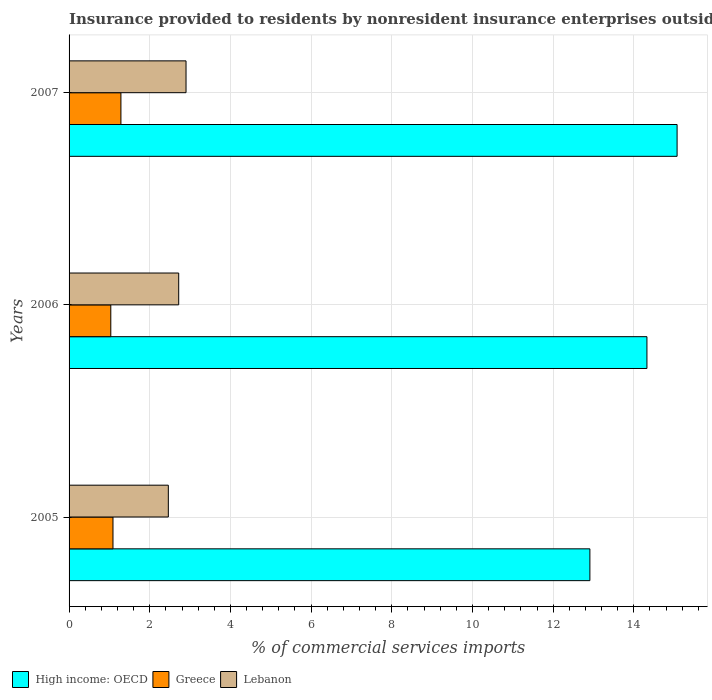How many bars are there on the 3rd tick from the top?
Give a very brief answer. 3. What is the label of the 2nd group of bars from the top?
Give a very brief answer. 2006. In how many cases, is the number of bars for a given year not equal to the number of legend labels?
Give a very brief answer. 0. What is the Insurance provided to residents in High income: OECD in 2006?
Offer a very short reply. 14.33. Across all years, what is the maximum Insurance provided to residents in Lebanon?
Keep it short and to the point. 2.9. Across all years, what is the minimum Insurance provided to residents in Greece?
Keep it short and to the point. 1.03. What is the total Insurance provided to residents in Greece in the graph?
Provide a short and direct response. 3.41. What is the difference between the Insurance provided to residents in Lebanon in 2005 and that in 2006?
Give a very brief answer. -0.26. What is the difference between the Insurance provided to residents in High income: OECD in 2005 and the Insurance provided to residents in Lebanon in 2007?
Offer a terse response. 10.01. What is the average Insurance provided to residents in Lebanon per year?
Keep it short and to the point. 2.69. In the year 2005, what is the difference between the Insurance provided to residents in Greece and Insurance provided to residents in Lebanon?
Give a very brief answer. -1.37. In how many years, is the Insurance provided to residents in High income: OECD greater than 9.2 %?
Offer a terse response. 3. What is the ratio of the Insurance provided to residents in High income: OECD in 2006 to that in 2007?
Provide a succinct answer. 0.95. Is the difference between the Insurance provided to residents in Greece in 2005 and 2007 greater than the difference between the Insurance provided to residents in Lebanon in 2005 and 2007?
Make the answer very short. Yes. What is the difference between the highest and the second highest Insurance provided to residents in Greece?
Provide a short and direct response. 0.2. What is the difference between the highest and the lowest Insurance provided to residents in Greece?
Offer a terse response. 0.25. What does the 1st bar from the bottom in 2006 represents?
Provide a succinct answer. High income: OECD. Are all the bars in the graph horizontal?
Make the answer very short. Yes. What is the difference between two consecutive major ticks on the X-axis?
Provide a short and direct response. 2. How many legend labels are there?
Ensure brevity in your answer.  3. How are the legend labels stacked?
Offer a very short reply. Horizontal. What is the title of the graph?
Offer a very short reply. Insurance provided to residents by nonresident insurance enterprises outside a country. What is the label or title of the X-axis?
Keep it short and to the point. % of commercial services imports. What is the label or title of the Y-axis?
Make the answer very short. Years. What is the % of commercial services imports in High income: OECD in 2005?
Make the answer very short. 12.91. What is the % of commercial services imports in Greece in 2005?
Provide a succinct answer. 1.09. What is the % of commercial services imports in Lebanon in 2005?
Your answer should be compact. 2.46. What is the % of commercial services imports in High income: OECD in 2006?
Provide a short and direct response. 14.33. What is the % of commercial services imports in Greece in 2006?
Keep it short and to the point. 1.03. What is the % of commercial services imports of Lebanon in 2006?
Your response must be concise. 2.72. What is the % of commercial services imports in High income: OECD in 2007?
Ensure brevity in your answer.  15.07. What is the % of commercial services imports in Greece in 2007?
Provide a succinct answer. 1.29. What is the % of commercial services imports in Lebanon in 2007?
Your response must be concise. 2.9. Across all years, what is the maximum % of commercial services imports in High income: OECD?
Provide a succinct answer. 15.07. Across all years, what is the maximum % of commercial services imports of Greece?
Make the answer very short. 1.29. Across all years, what is the maximum % of commercial services imports in Lebanon?
Your answer should be compact. 2.9. Across all years, what is the minimum % of commercial services imports in High income: OECD?
Offer a very short reply. 12.91. Across all years, what is the minimum % of commercial services imports of Greece?
Provide a succinct answer. 1.03. Across all years, what is the minimum % of commercial services imports in Lebanon?
Provide a short and direct response. 2.46. What is the total % of commercial services imports of High income: OECD in the graph?
Ensure brevity in your answer.  42.31. What is the total % of commercial services imports in Greece in the graph?
Provide a succinct answer. 3.41. What is the total % of commercial services imports in Lebanon in the graph?
Your answer should be very brief. 8.08. What is the difference between the % of commercial services imports of High income: OECD in 2005 and that in 2006?
Provide a succinct answer. -1.41. What is the difference between the % of commercial services imports in Greece in 2005 and that in 2006?
Provide a short and direct response. 0.05. What is the difference between the % of commercial services imports in Lebanon in 2005 and that in 2006?
Offer a terse response. -0.26. What is the difference between the % of commercial services imports in High income: OECD in 2005 and that in 2007?
Make the answer very short. -2.16. What is the difference between the % of commercial services imports in Greece in 2005 and that in 2007?
Your response must be concise. -0.2. What is the difference between the % of commercial services imports in Lebanon in 2005 and that in 2007?
Provide a succinct answer. -0.44. What is the difference between the % of commercial services imports in High income: OECD in 2006 and that in 2007?
Keep it short and to the point. -0.75. What is the difference between the % of commercial services imports in Greece in 2006 and that in 2007?
Your answer should be compact. -0.25. What is the difference between the % of commercial services imports in Lebanon in 2006 and that in 2007?
Offer a very short reply. -0.18. What is the difference between the % of commercial services imports of High income: OECD in 2005 and the % of commercial services imports of Greece in 2006?
Offer a very short reply. 11.88. What is the difference between the % of commercial services imports in High income: OECD in 2005 and the % of commercial services imports in Lebanon in 2006?
Provide a succinct answer. 10.19. What is the difference between the % of commercial services imports of Greece in 2005 and the % of commercial services imports of Lebanon in 2006?
Your answer should be very brief. -1.63. What is the difference between the % of commercial services imports of High income: OECD in 2005 and the % of commercial services imports of Greece in 2007?
Your response must be concise. 11.63. What is the difference between the % of commercial services imports in High income: OECD in 2005 and the % of commercial services imports in Lebanon in 2007?
Keep it short and to the point. 10.01. What is the difference between the % of commercial services imports in Greece in 2005 and the % of commercial services imports in Lebanon in 2007?
Offer a very short reply. -1.81. What is the difference between the % of commercial services imports of High income: OECD in 2006 and the % of commercial services imports of Greece in 2007?
Your answer should be very brief. 13.04. What is the difference between the % of commercial services imports of High income: OECD in 2006 and the % of commercial services imports of Lebanon in 2007?
Your answer should be very brief. 11.43. What is the difference between the % of commercial services imports in Greece in 2006 and the % of commercial services imports in Lebanon in 2007?
Offer a very short reply. -1.87. What is the average % of commercial services imports of High income: OECD per year?
Offer a very short reply. 14.1. What is the average % of commercial services imports in Greece per year?
Provide a succinct answer. 1.14. What is the average % of commercial services imports in Lebanon per year?
Ensure brevity in your answer.  2.69. In the year 2005, what is the difference between the % of commercial services imports of High income: OECD and % of commercial services imports of Greece?
Keep it short and to the point. 11.82. In the year 2005, what is the difference between the % of commercial services imports in High income: OECD and % of commercial services imports in Lebanon?
Your answer should be compact. 10.45. In the year 2005, what is the difference between the % of commercial services imports in Greece and % of commercial services imports in Lebanon?
Your response must be concise. -1.37. In the year 2006, what is the difference between the % of commercial services imports of High income: OECD and % of commercial services imports of Greece?
Your answer should be very brief. 13.29. In the year 2006, what is the difference between the % of commercial services imports in High income: OECD and % of commercial services imports in Lebanon?
Make the answer very short. 11.61. In the year 2006, what is the difference between the % of commercial services imports of Greece and % of commercial services imports of Lebanon?
Give a very brief answer. -1.68. In the year 2007, what is the difference between the % of commercial services imports of High income: OECD and % of commercial services imports of Greece?
Offer a terse response. 13.79. In the year 2007, what is the difference between the % of commercial services imports of High income: OECD and % of commercial services imports of Lebanon?
Make the answer very short. 12.17. In the year 2007, what is the difference between the % of commercial services imports of Greece and % of commercial services imports of Lebanon?
Keep it short and to the point. -1.61. What is the ratio of the % of commercial services imports of High income: OECD in 2005 to that in 2006?
Your answer should be compact. 0.9. What is the ratio of the % of commercial services imports in Greece in 2005 to that in 2006?
Your answer should be very brief. 1.05. What is the ratio of the % of commercial services imports of Lebanon in 2005 to that in 2006?
Provide a short and direct response. 0.91. What is the ratio of the % of commercial services imports of High income: OECD in 2005 to that in 2007?
Provide a short and direct response. 0.86. What is the ratio of the % of commercial services imports of Greece in 2005 to that in 2007?
Your answer should be very brief. 0.85. What is the ratio of the % of commercial services imports in Lebanon in 2005 to that in 2007?
Give a very brief answer. 0.85. What is the ratio of the % of commercial services imports in High income: OECD in 2006 to that in 2007?
Your answer should be very brief. 0.95. What is the ratio of the % of commercial services imports of Greece in 2006 to that in 2007?
Keep it short and to the point. 0.8. What is the ratio of the % of commercial services imports of Lebanon in 2006 to that in 2007?
Your response must be concise. 0.94. What is the difference between the highest and the second highest % of commercial services imports in High income: OECD?
Ensure brevity in your answer.  0.75. What is the difference between the highest and the second highest % of commercial services imports of Greece?
Offer a terse response. 0.2. What is the difference between the highest and the second highest % of commercial services imports of Lebanon?
Ensure brevity in your answer.  0.18. What is the difference between the highest and the lowest % of commercial services imports of High income: OECD?
Your answer should be very brief. 2.16. What is the difference between the highest and the lowest % of commercial services imports of Greece?
Offer a terse response. 0.25. What is the difference between the highest and the lowest % of commercial services imports of Lebanon?
Offer a very short reply. 0.44. 